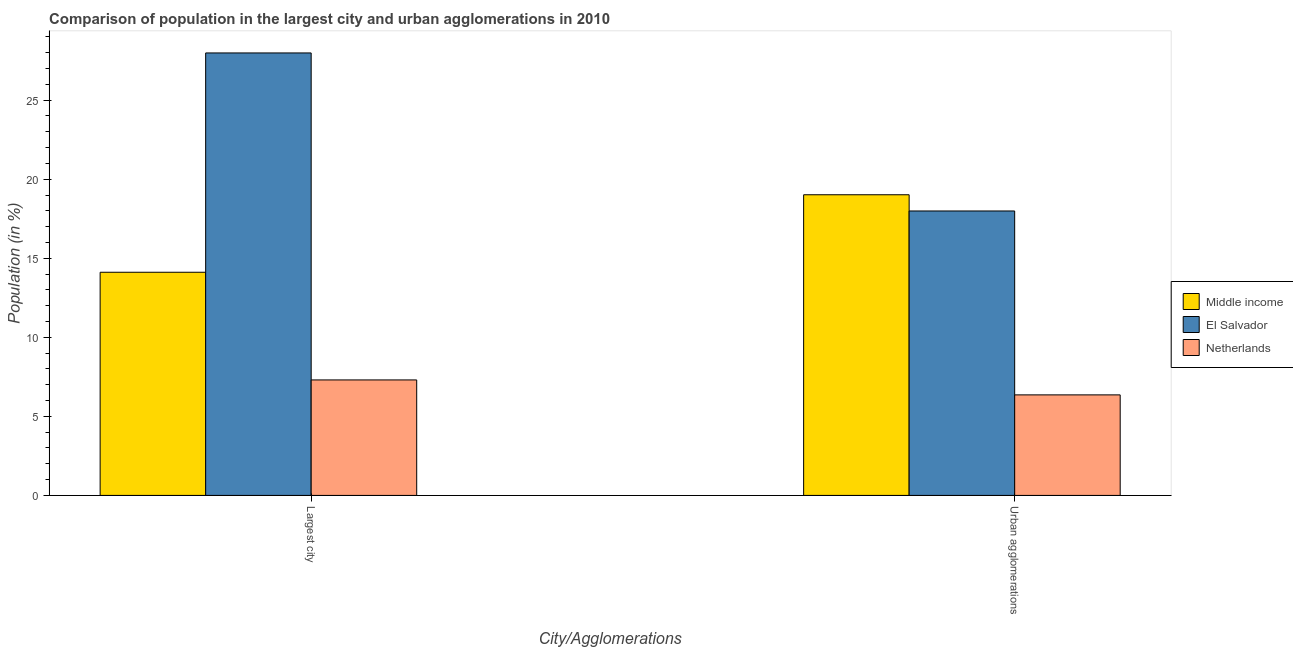How many different coloured bars are there?
Provide a succinct answer. 3. How many groups of bars are there?
Offer a very short reply. 2. Are the number of bars on each tick of the X-axis equal?
Keep it short and to the point. Yes. How many bars are there on the 2nd tick from the left?
Ensure brevity in your answer.  3. How many bars are there on the 2nd tick from the right?
Provide a short and direct response. 3. What is the label of the 1st group of bars from the left?
Your response must be concise. Largest city. What is the population in the largest city in Netherlands?
Provide a succinct answer. 7.3. Across all countries, what is the maximum population in the largest city?
Your response must be concise. 27.99. Across all countries, what is the minimum population in urban agglomerations?
Offer a terse response. 6.36. In which country was the population in the largest city maximum?
Ensure brevity in your answer.  El Salvador. What is the total population in the largest city in the graph?
Make the answer very short. 49.41. What is the difference between the population in the largest city in El Salvador and that in Middle income?
Your answer should be compact. 13.87. What is the difference between the population in urban agglomerations in Netherlands and the population in the largest city in El Salvador?
Offer a terse response. -21.63. What is the average population in the largest city per country?
Provide a succinct answer. 16.47. What is the difference between the population in the largest city and population in urban agglomerations in Middle income?
Your response must be concise. -4.9. In how many countries, is the population in the largest city greater than 19 %?
Give a very brief answer. 1. What is the ratio of the population in urban agglomerations in El Salvador to that in Middle income?
Make the answer very short. 0.95. What does the 1st bar from the right in Urban agglomerations represents?
Offer a terse response. Netherlands. How many bars are there?
Ensure brevity in your answer.  6. Are all the bars in the graph horizontal?
Your response must be concise. No. How many countries are there in the graph?
Your answer should be compact. 3. Does the graph contain any zero values?
Provide a short and direct response. No. How many legend labels are there?
Ensure brevity in your answer.  3. What is the title of the graph?
Give a very brief answer. Comparison of population in the largest city and urban agglomerations in 2010. What is the label or title of the X-axis?
Your answer should be very brief. City/Agglomerations. What is the label or title of the Y-axis?
Your answer should be compact. Population (in %). What is the Population (in %) in Middle income in Largest city?
Make the answer very short. 14.12. What is the Population (in %) in El Salvador in Largest city?
Offer a very short reply. 27.99. What is the Population (in %) in Netherlands in Largest city?
Give a very brief answer. 7.3. What is the Population (in %) in Middle income in Urban agglomerations?
Your answer should be compact. 19.02. What is the Population (in %) in El Salvador in Urban agglomerations?
Provide a succinct answer. 17.99. What is the Population (in %) of Netherlands in Urban agglomerations?
Your answer should be compact. 6.36. Across all City/Agglomerations, what is the maximum Population (in %) of Middle income?
Provide a succinct answer. 19.02. Across all City/Agglomerations, what is the maximum Population (in %) of El Salvador?
Offer a terse response. 27.99. Across all City/Agglomerations, what is the maximum Population (in %) in Netherlands?
Your answer should be very brief. 7.3. Across all City/Agglomerations, what is the minimum Population (in %) of Middle income?
Your answer should be very brief. 14.12. Across all City/Agglomerations, what is the minimum Population (in %) in El Salvador?
Provide a short and direct response. 17.99. Across all City/Agglomerations, what is the minimum Population (in %) in Netherlands?
Give a very brief answer. 6.36. What is the total Population (in %) of Middle income in the graph?
Make the answer very short. 33.13. What is the total Population (in %) of El Salvador in the graph?
Provide a succinct answer. 45.98. What is the total Population (in %) of Netherlands in the graph?
Your answer should be very brief. 13.66. What is the difference between the Population (in %) of Middle income in Largest city and that in Urban agglomerations?
Ensure brevity in your answer.  -4.9. What is the difference between the Population (in %) of El Salvador in Largest city and that in Urban agglomerations?
Your answer should be very brief. 10. What is the difference between the Population (in %) in Netherlands in Largest city and that in Urban agglomerations?
Your response must be concise. 0.95. What is the difference between the Population (in %) in Middle income in Largest city and the Population (in %) in El Salvador in Urban agglomerations?
Your response must be concise. -3.88. What is the difference between the Population (in %) of Middle income in Largest city and the Population (in %) of Netherlands in Urban agglomerations?
Your response must be concise. 7.76. What is the difference between the Population (in %) in El Salvador in Largest city and the Population (in %) in Netherlands in Urban agglomerations?
Offer a very short reply. 21.63. What is the average Population (in %) in Middle income per City/Agglomerations?
Offer a terse response. 16.57. What is the average Population (in %) of El Salvador per City/Agglomerations?
Keep it short and to the point. 22.99. What is the average Population (in %) in Netherlands per City/Agglomerations?
Ensure brevity in your answer.  6.83. What is the difference between the Population (in %) in Middle income and Population (in %) in El Salvador in Largest city?
Make the answer very short. -13.87. What is the difference between the Population (in %) in Middle income and Population (in %) in Netherlands in Largest city?
Give a very brief answer. 6.81. What is the difference between the Population (in %) in El Salvador and Population (in %) in Netherlands in Largest city?
Make the answer very short. 20.68. What is the difference between the Population (in %) in Middle income and Population (in %) in El Salvador in Urban agglomerations?
Your response must be concise. 1.03. What is the difference between the Population (in %) in Middle income and Population (in %) in Netherlands in Urban agglomerations?
Give a very brief answer. 12.66. What is the difference between the Population (in %) of El Salvador and Population (in %) of Netherlands in Urban agglomerations?
Offer a very short reply. 11.63. What is the ratio of the Population (in %) in Middle income in Largest city to that in Urban agglomerations?
Your answer should be very brief. 0.74. What is the ratio of the Population (in %) in El Salvador in Largest city to that in Urban agglomerations?
Your response must be concise. 1.56. What is the ratio of the Population (in %) in Netherlands in Largest city to that in Urban agglomerations?
Your answer should be very brief. 1.15. What is the difference between the highest and the second highest Population (in %) in Middle income?
Keep it short and to the point. 4.9. What is the difference between the highest and the second highest Population (in %) of El Salvador?
Keep it short and to the point. 10. What is the difference between the highest and the second highest Population (in %) in Netherlands?
Your answer should be compact. 0.95. What is the difference between the highest and the lowest Population (in %) of Middle income?
Keep it short and to the point. 4.9. What is the difference between the highest and the lowest Population (in %) of El Salvador?
Make the answer very short. 10. What is the difference between the highest and the lowest Population (in %) of Netherlands?
Offer a very short reply. 0.95. 